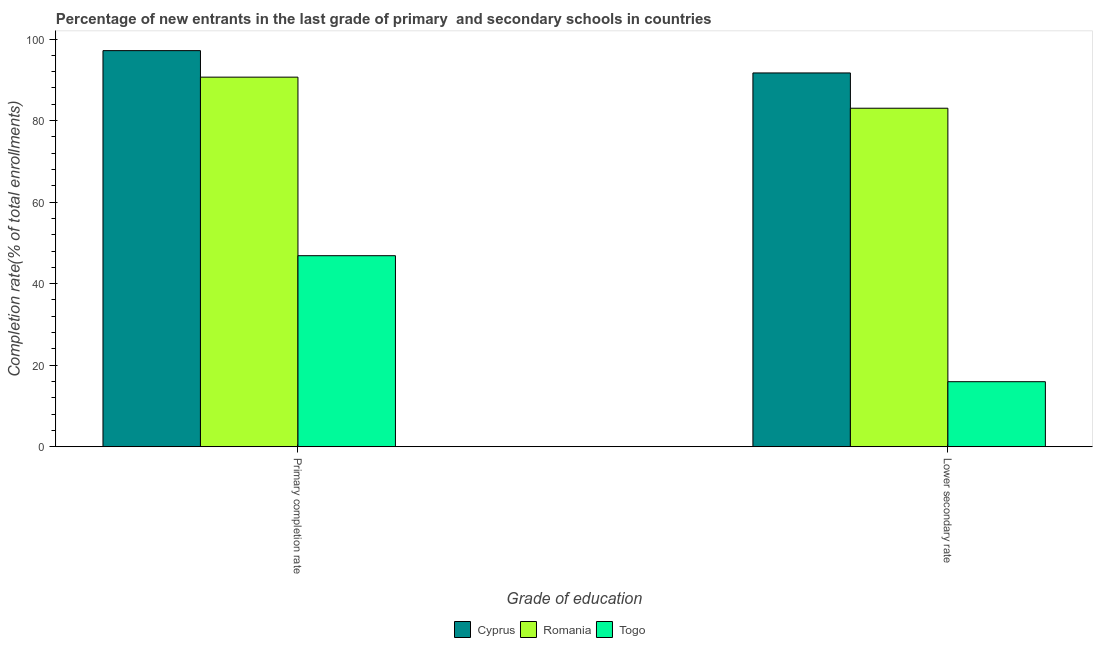How many different coloured bars are there?
Give a very brief answer. 3. Are the number of bars on each tick of the X-axis equal?
Your response must be concise. Yes. How many bars are there on the 1st tick from the left?
Your answer should be very brief. 3. How many bars are there on the 2nd tick from the right?
Offer a terse response. 3. What is the label of the 2nd group of bars from the left?
Keep it short and to the point. Lower secondary rate. What is the completion rate in primary schools in Cyprus?
Your answer should be very brief. 97.16. Across all countries, what is the maximum completion rate in primary schools?
Offer a terse response. 97.16. Across all countries, what is the minimum completion rate in secondary schools?
Offer a very short reply. 15.95. In which country was the completion rate in primary schools maximum?
Keep it short and to the point. Cyprus. In which country was the completion rate in secondary schools minimum?
Your answer should be compact. Togo. What is the total completion rate in secondary schools in the graph?
Make the answer very short. 190.67. What is the difference between the completion rate in secondary schools in Togo and that in Cyprus?
Give a very brief answer. -75.73. What is the difference between the completion rate in primary schools in Cyprus and the completion rate in secondary schools in Romania?
Offer a very short reply. 14.13. What is the average completion rate in secondary schools per country?
Your answer should be compact. 63.56. What is the difference between the completion rate in primary schools and completion rate in secondary schools in Romania?
Offer a very short reply. 7.62. What is the ratio of the completion rate in primary schools in Cyprus to that in Romania?
Your answer should be very brief. 1.07. Is the completion rate in secondary schools in Romania less than that in Togo?
Your answer should be very brief. No. In how many countries, is the completion rate in primary schools greater than the average completion rate in primary schools taken over all countries?
Keep it short and to the point. 2. What does the 3rd bar from the left in Primary completion rate represents?
Your response must be concise. Togo. What does the 3rd bar from the right in Primary completion rate represents?
Give a very brief answer. Cyprus. Are all the bars in the graph horizontal?
Your answer should be compact. No. What is the difference between two consecutive major ticks on the Y-axis?
Your answer should be very brief. 20. Does the graph contain any zero values?
Keep it short and to the point. No. Does the graph contain grids?
Make the answer very short. No. Where does the legend appear in the graph?
Keep it short and to the point. Bottom center. How are the legend labels stacked?
Offer a very short reply. Horizontal. What is the title of the graph?
Your answer should be compact. Percentage of new entrants in the last grade of primary  and secondary schools in countries. Does "Myanmar" appear as one of the legend labels in the graph?
Give a very brief answer. No. What is the label or title of the X-axis?
Give a very brief answer. Grade of education. What is the label or title of the Y-axis?
Provide a short and direct response. Completion rate(% of total enrollments). What is the Completion rate(% of total enrollments) of Cyprus in Primary completion rate?
Offer a terse response. 97.16. What is the Completion rate(% of total enrollments) in Romania in Primary completion rate?
Offer a very short reply. 90.65. What is the Completion rate(% of total enrollments) of Togo in Primary completion rate?
Provide a short and direct response. 46.86. What is the Completion rate(% of total enrollments) in Cyprus in Lower secondary rate?
Offer a very short reply. 91.69. What is the Completion rate(% of total enrollments) of Romania in Lower secondary rate?
Make the answer very short. 83.03. What is the Completion rate(% of total enrollments) in Togo in Lower secondary rate?
Keep it short and to the point. 15.95. Across all Grade of education, what is the maximum Completion rate(% of total enrollments) in Cyprus?
Provide a short and direct response. 97.16. Across all Grade of education, what is the maximum Completion rate(% of total enrollments) in Romania?
Give a very brief answer. 90.65. Across all Grade of education, what is the maximum Completion rate(% of total enrollments) of Togo?
Ensure brevity in your answer.  46.86. Across all Grade of education, what is the minimum Completion rate(% of total enrollments) in Cyprus?
Offer a terse response. 91.69. Across all Grade of education, what is the minimum Completion rate(% of total enrollments) of Romania?
Your answer should be very brief. 83.03. Across all Grade of education, what is the minimum Completion rate(% of total enrollments) in Togo?
Your answer should be compact. 15.95. What is the total Completion rate(% of total enrollments) in Cyprus in the graph?
Offer a terse response. 188.84. What is the total Completion rate(% of total enrollments) of Romania in the graph?
Your answer should be very brief. 173.68. What is the total Completion rate(% of total enrollments) of Togo in the graph?
Keep it short and to the point. 62.81. What is the difference between the Completion rate(% of total enrollments) in Cyprus in Primary completion rate and that in Lower secondary rate?
Offer a terse response. 5.47. What is the difference between the Completion rate(% of total enrollments) of Romania in Primary completion rate and that in Lower secondary rate?
Offer a terse response. 7.62. What is the difference between the Completion rate(% of total enrollments) of Togo in Primary completion rate and that in Lower secondary rate?
Your answer should be very brief. 30.91. What is the difference between the Completion rate(% of total enrollments) in Cyprus in Primary completion rate and the Completion rate(% of total enrollments) in Romania in Lower secondary rate?
Make the answer very short. 14.13. What is the difference between the Completion rate(% of total enrollments) of Cyprus in Primary completion rate and the Completion rate(% of total enrollments) of Togo in Lower secondary rate?
Your answer should be compact. 81.21. What is the difference between the Completion rate(% of total enrollments) in Romania in Primary completion rate and the Completion rate(% of total enrollments) in Togo in Lower secondary rate?
Make the answer very short. 74.7. What is the average Completion rate(% of total enrollments) in Cyprus per Grade of education?
Offer a very short reply. 94.42. What is the average Completion rate(% of total enrollments) of Romania per Grade of education?
Your response must be concise. 86.84. What is the average Completion rate(% of total enrollments) of Togo per Grade of education?
Your answer should be very brief. 31.4. What is the difference between the Completion rate(% of total enrollments) in Cyprus and Completion rate(% of total enrollments) in Romania in Primary completion rate?
Offer a terse response. 6.5. What is the difference between the Completion rate(% of total enrollments) of Cyprus and Completion rate(% of total enrollments) of Togo in Primary completion rate?
Your answer should be very brief. 50.3. What is the difference between the Completion rate(% of total enrollments) in Romania and Completion rate(% of total enrollments) in Togo in Primary completion rate?
Provide a short and direct response. 43.8. What is the difference between the Completion rate(% of total enrollments) in Cyprus and Completion rate(% of total enrollments) in Romania in Lower secondary rate?
Provide a succinct answer. 8.66. What is the difference between the Completion rate(% of total enrollments) of Cyprus and Completion rate(% of total enrollments) of Togo in Lower secondary rate?
Provide a succinct answer. 75.73. What is the difference between the Completion rate(% of total enrollments) of Romania and Completion rate(% of total enrollments) of Togo in Lower secondary rate?
Make the answer very short. 67.08. What is the ratio of the Completion rate(% of total enrollments) in Cyprus in Primary completion rate to that in Lower secondary rate?
Your answer should be very brief. 1.06. What is the ratio of the Completion rate(% of total enrollments) in Romania in Primary completion rate to that in Lower secondary rate?
Provide a succinct answer. 1.09. What is the ratio of the Completion rate(% of total enrollments) of Togo in Primary completion rate to that in Lower secondary rate?
Your response must be concise. 2.94. What is the difference between the highest and the second highest Completion rate(% of total enrollments) in Cyprus?
Your answer should be compact. 5.47. What is the difference between the highest and the second highest Completion rate(% of total enrollments) in Romania?
Your answer should be very brief. 7.62. What is the difference between the highest and the second highest Completion rate(% of total enrollments) in Togo?
Your answer should be compact. 30.91. What is the difference between the highest and the lowest Completion rate(% of total enrollments) in Cyprus?
Keep it short and to the point. 5.47. What is the difference between the highest and the lowest Completion rate(% of total enrollments) of Romania?
Give a very brief answer. 7.62. What is the difference between the highest and the lowest Completion rate(% of total enrollments) of Togo?
Give a very brief answer. 30.91. 